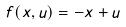Convert formula to latex. <formula><loc_0><loc_0><loc_500><loc_500>f ( x , u ) = - x + u</formula> 